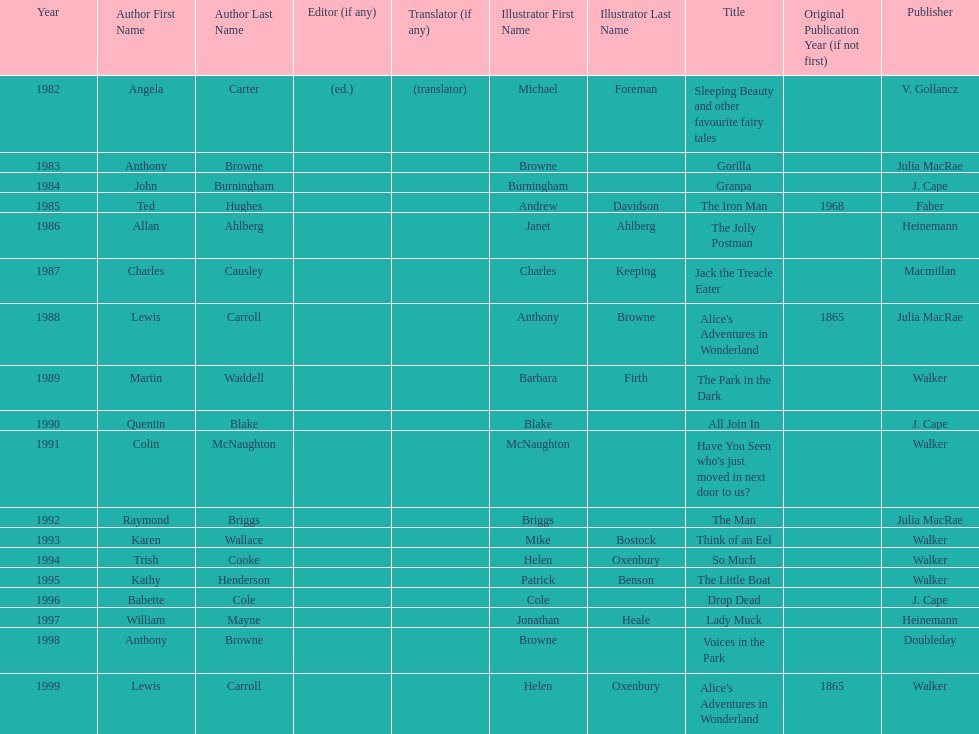Could you help me parse every detail presented in this table? {'header': ['Year', 'Author First Name', 'Author Last Name', 'Editor (if any)', 'Translator (if any)', 'Illustrator First Name', 'Illustrator Last Name', 'Title', 'Original Publication Year (if not first)', 'Publisher'], 'rows': [['1982', 'Angela', 'Carter', '(ed.)', '(translator)', 'Michael', 'Foreman', 'Sleeping Beauty and other favourite fairy tales', '', 'V. Gollancz'], ['1983', 'Anthony', 'Browne', '', '', 'Browne', '', 'Gorilla', '', 'Julia MacRae'], ['1984', 'John', 'Burningham', '', '', 'Burningham', '', 'Granpa', '', 'J. Cape'], ['1985', 'Ted', 'Hughes', '', '', 'Andrew', 'Davidson', 'The Iron Man', '1968', 'Faber'], ['1986', 'Allan', 'Ahlberg', '', '', 'Janet', 'Ahlberg', 'The Jolly Postman', '', 'Heinemann'], ['1987', 'Charles', 'Causley', '', '', 'Charles', 'Keeping', 'Jack the Treacle Eater', '', 'Macmillan'], ['1988', 'Lewis', 'Carroll', '', '', 'Anthony', 'Browne', "Alice's Adventures in Wonderland", '1865', 'Julia MacRae'], ['1989', 'Martin', 'Waddell', '', '', 'Barbara', 'Firth', 'The Park in the Dark', '', 'Walker'], ['1990', 'Quentin', 'Blake', '', '', 'Blake', '', 'All Join In', '', 'J. Cape'], ['1991', 'Colin', 'McNaughton', '', '', 'McNaughton', '', "Have You Seen who's just moved in next door to us?", '', 'Walker'], ['1992', 'Raymond', 'Briggs', '', '', 'Briggs', '', 'The Man', '', 'Julia MacRae'], ['1993', 'Karen', 'Wallace', '', '', 'Mike', 'Bostock', 'Think of an Eel', '', 'Walker'], ['1994', 'Trish', 'Cooke', '', '', 'Helen', 'Oxenbury', 'So Much', '', 'Walker'], ['1995', 'Kathy', 'Henderson', '', '', 'Patrick', 'Benson', 'The Little Boat', '', 'Walker'], ['1996', 'Babette', 'Cole', '', '', 'Cole', '', 'Drop Dead', '', 'J. Cape'], ['1997', 'William', 'Mayne', '', '', 'Jonathan', 'Heale', 'Lady Muck', '', 'Heinemann'], ['1998', 'Anthony', 'Browne', '', '', 'Browne', '', 'Voices in the Park', '', 'Doubleday'], ['1999', 'Lewis', 'Carroll', '', '', 'Helen', 'Oxenbury', "Alice's Adventures in Wonderland", '1865', 'Walker']]} Which author wrote the first award winner? Angela Carter. 